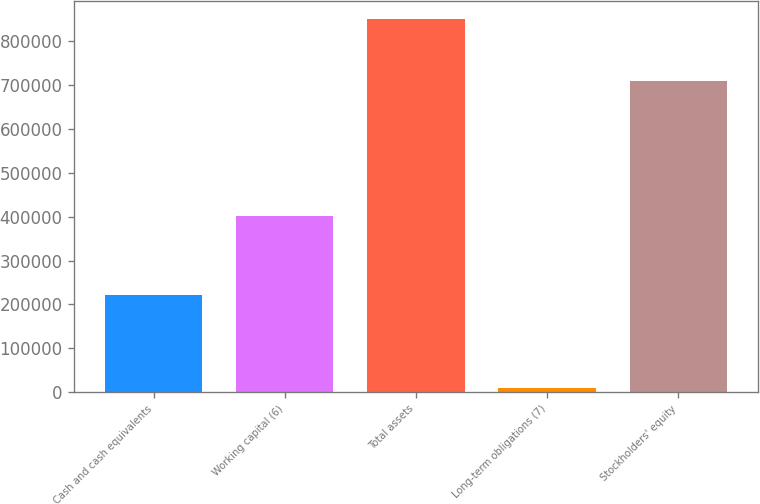<chart> <loc_0><loc_0><loc_500><loc_500><bar_chart><fcel>Cash and cash equivalents<fcel>Working capital (6)<fcel>Total assets<fcel>Long-term obligations (7)<fcel>Stockholders' equity<nl><fcel>221409<fcel>400883<fcel>850878<fcel>9345<fcel>710738<nl></chart> 